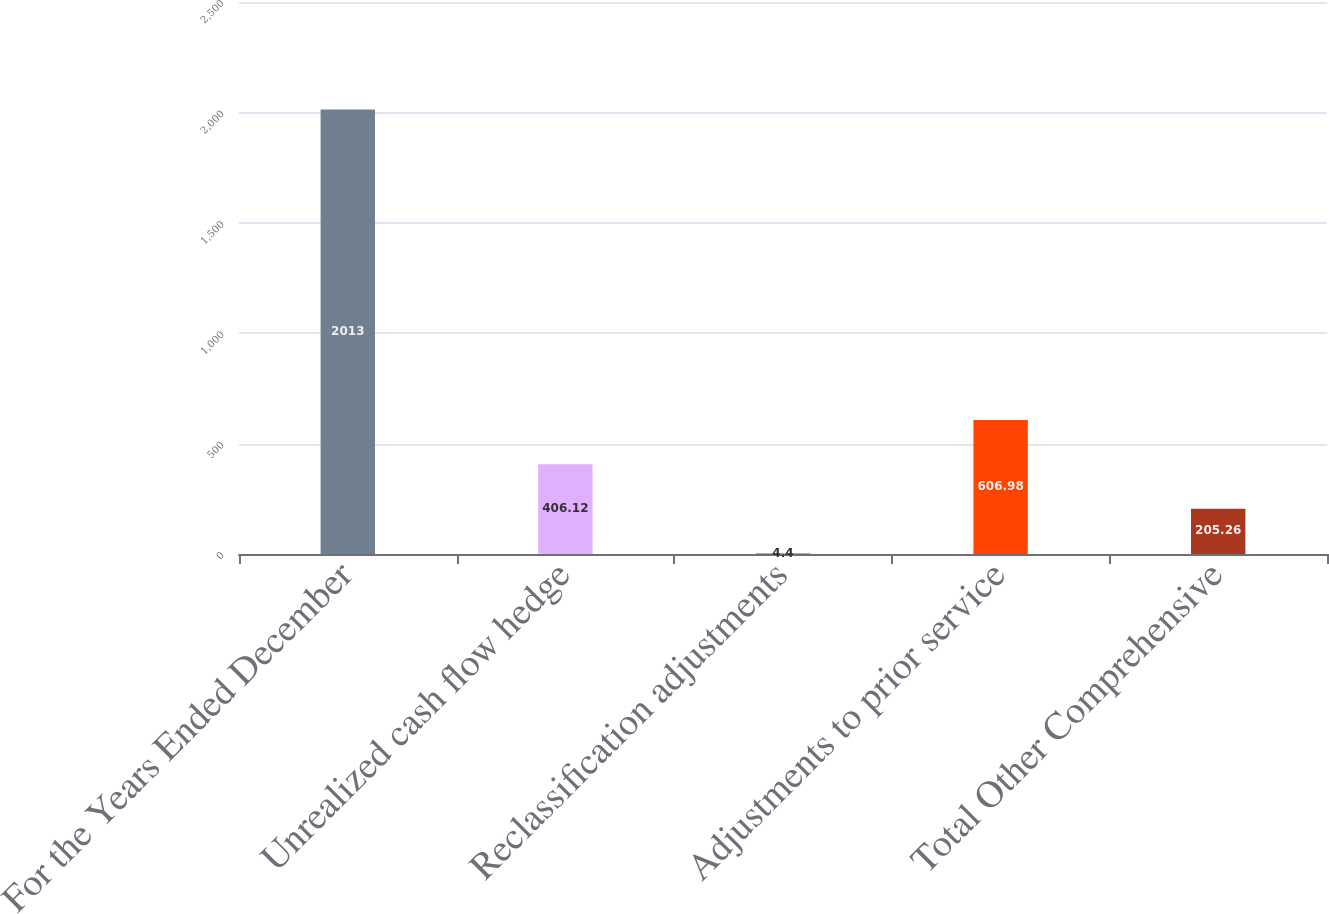Convert chart. <chart><loc_0><loc_0><loc_500><loc_500><bar_chart><fcel>For the Years Ended December<fcel>Unrealized cash flow hedge<fcel>Reclassification adjustments<fcel>Adjustments to prior service<fcel>Total Other Comprehensive<nl><fcel>2013<fcel>406.12<fcel>4.4<fcel>606.98<fcel>205.26<nl></chart> 